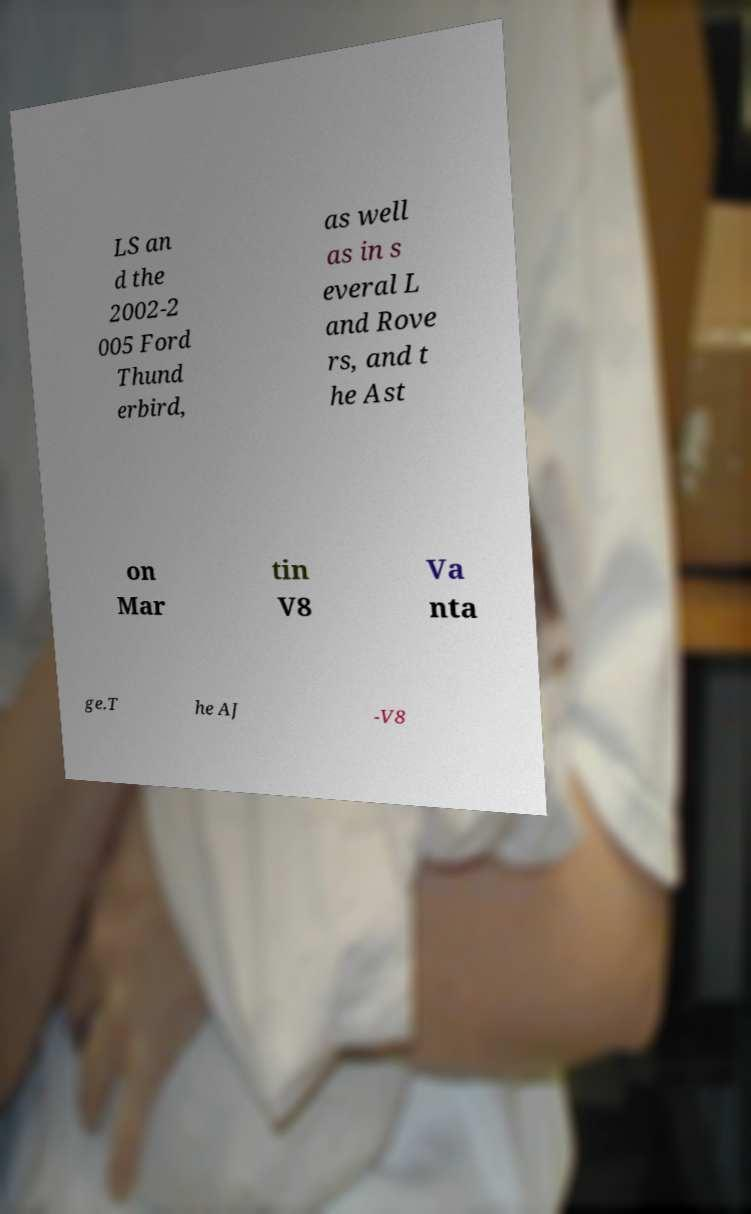For documentation purposes, I need the text within this image transcribed. Could you provide that? LS an d the 2002-2 005 Ford Thund erbird, as well as in s everal L and Rove rs, and t he Ast on Mar tin V8 Va nta ge.T he AJ -V8 